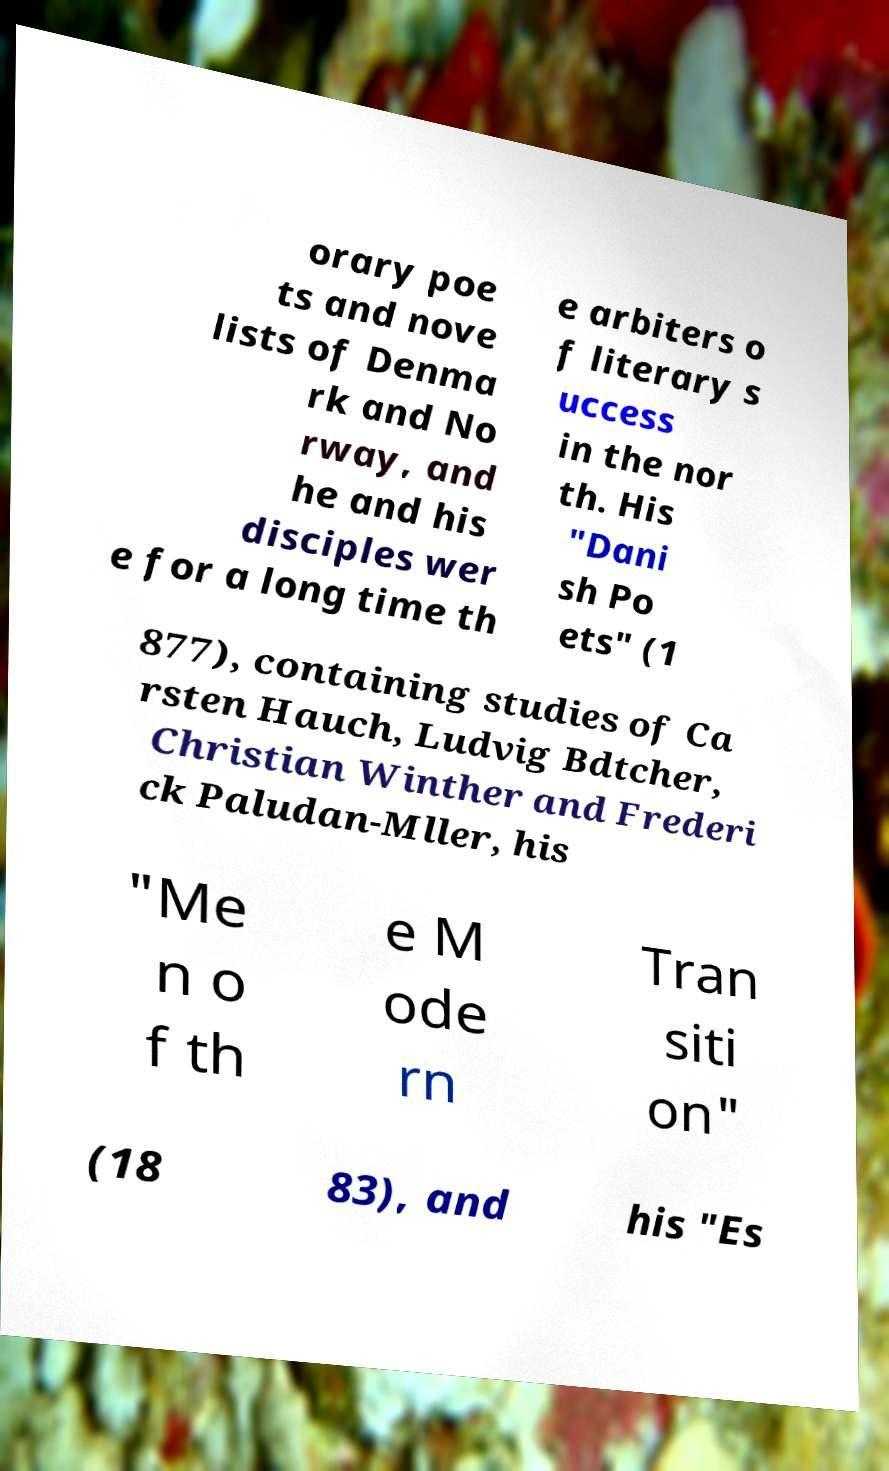Please identify and transcribe the text found in this image. orary poe ts and nove lists of Denma rk and No rway, and he and his disciples wer e for a long time th e arbiters o f literary s uccess in the nor th. His "Dani sh Po ets" (1 877), containing studies of Ca rsten Hauch, Ludvig Bdtcher, Christian Winther and Frederi ck Paludan-Mller, his "Me n o f th e M ode rn Tran siti on" (18 83), and his "Es 